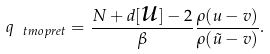<formula> <loc_0><loc_0><loc_500><loc_500>q _ { \ t m o p { r e t } } = \frac { N + d [ \text {$u$} ] - 2 } { \beta } \frac { \rho ( u - v ) } { \rho ( \tilde { u } - v ) } .</formula> 